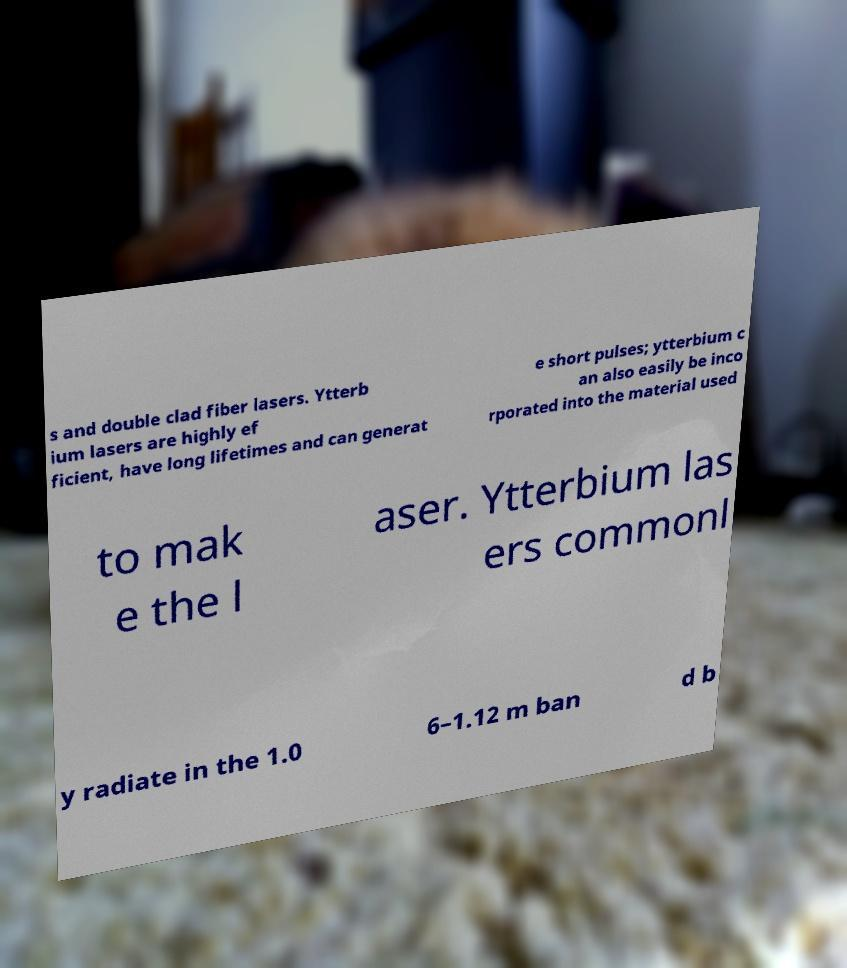Could you assist in decoding the text presented in this image and type it out clearly? s and double clad fiber lasers. Ytterb ium lasers are highly ef ficient, have long lifetimes and can generat e short pulses; ytterbium c an also easily be inco rporated into the material used to mak e the l aser. Ytterbium las ers commonl y radiate in the 1.0 6–1.12 m ban d b 